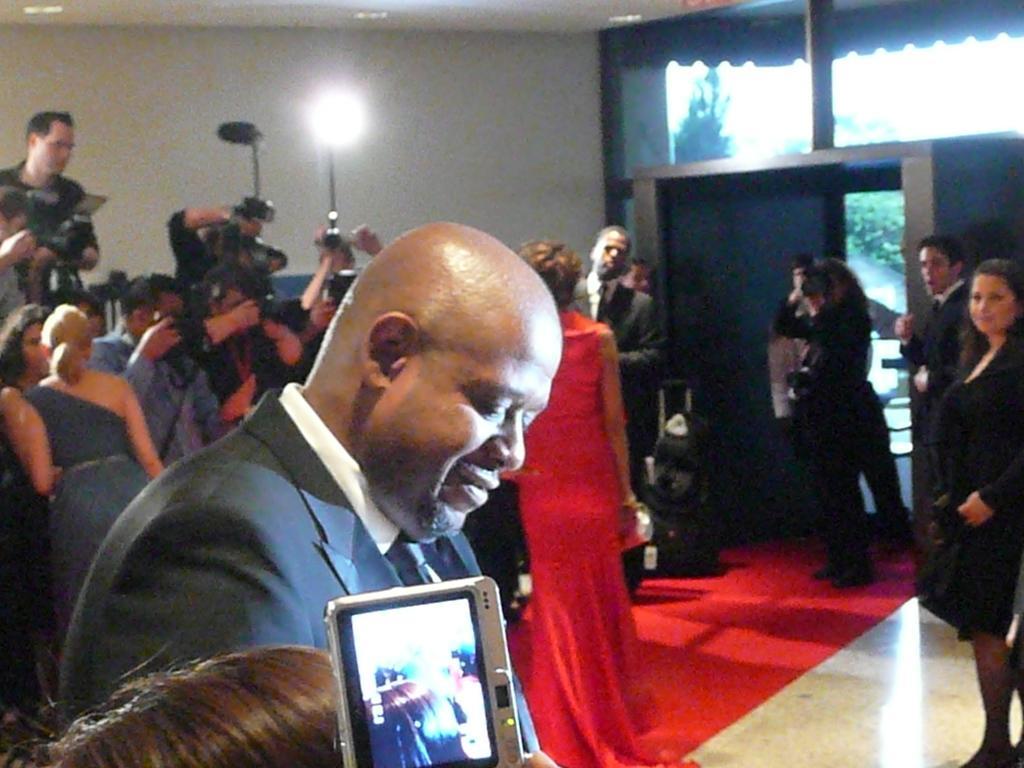Could you give a brief overview of what you see in this image? In this picture we can see some people are standing, some of the people on the left side are holding cameras, there is another camera at the bottom, in the background we can see a tree, we can also see a wall and a light in the background. 